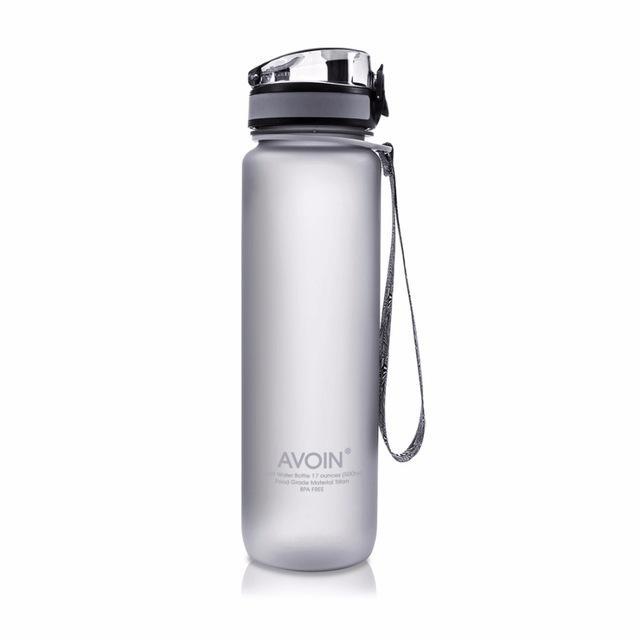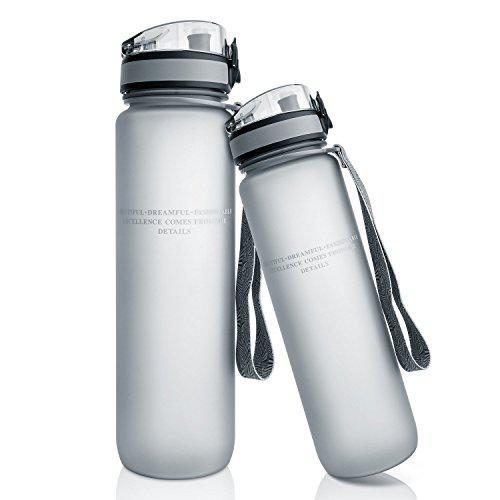The first image is the image on the left, the second image is the image on the right. Examine the images to the left and right. Is the description "There is a single closed bottle in the right image." accurate? Answer yes or no. No. The first image is the image on the left, the second image is the image on the right. For the images displayed, is the sentence "At least one of the water bottles has other objects next to it." factually correct? Answer yes or no. No. 